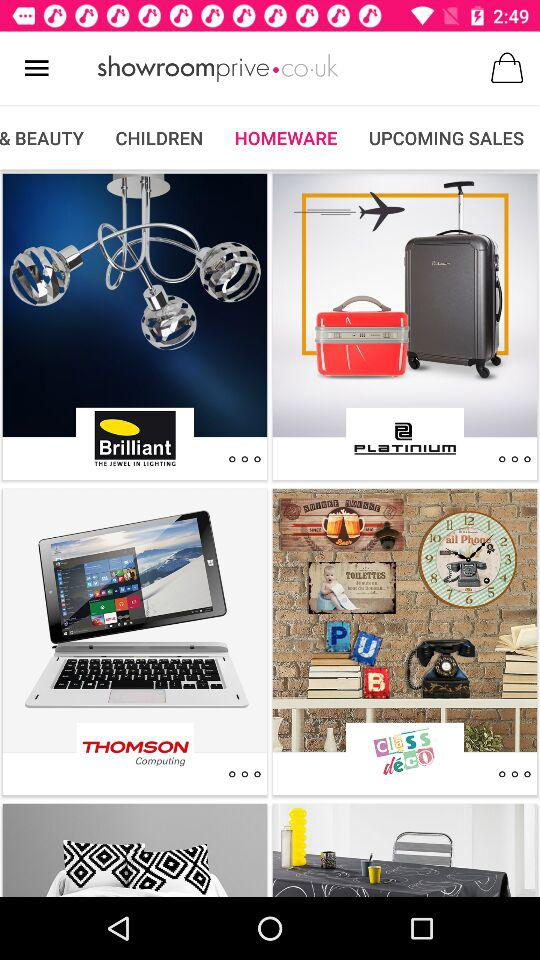What tab is selected? The selected tab is "HOMEWARE". 